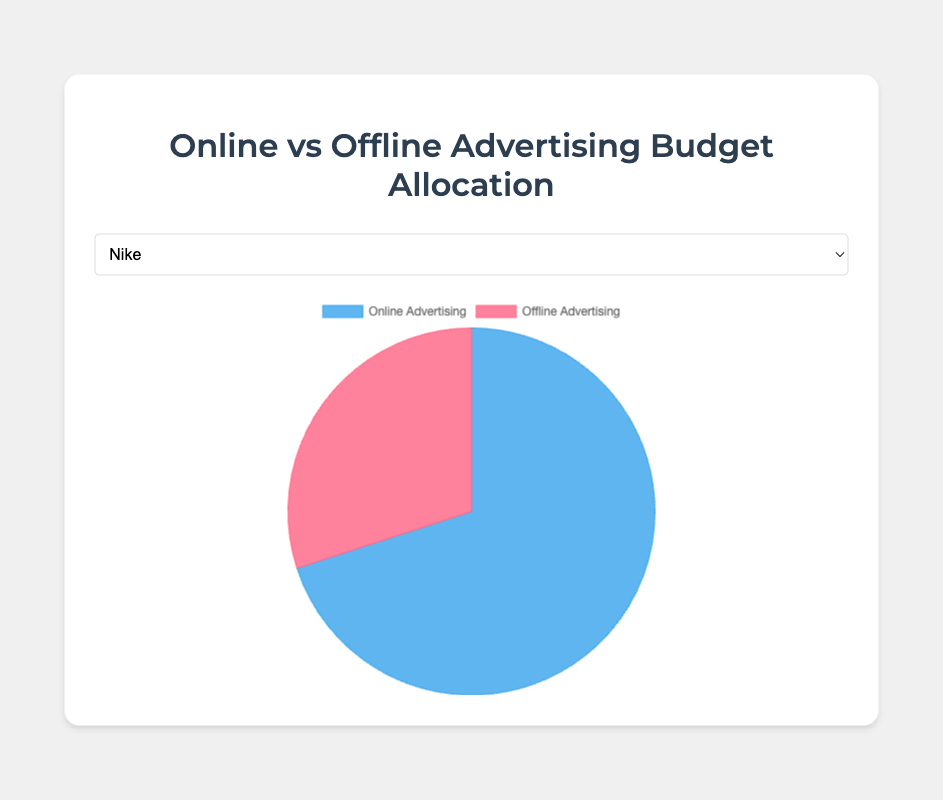Which company allocates the highest percentage to online advertising? By looking at the pie charts for each company, the segment representing online advertising is the largest for Nike at 70%.
Answer: Nike Which company has an equal distribution between online and offline advertising budgets? The pie chart for Pepsi shows that both segments are equal sized, each representing 50%.
Answer: Pepsi How much more does Samsung allocate to online advertising compared to offline advertising? Samsung's pie chart shows 65% for online and 35% for offline. The difference is 65% - 35% = 30%.
Answer: 30% Which company's offline advertising budget is 10% higher than its online advertising budget? By evaluating the pie charts, Apple's offline advertising budget is 40%, and its online is 60%, meaning offline is not 10% higher. No such company exists.
Answer: No such company What is the average online advertising budget percentage for Nike, Apple, and Coca-Cola combined? Nike: 70%, Apple: 60%, Coca-Cola: 55%. Average = (70 + 60 + 55) / 3 = 61.67%.
Answer: 61.67% If you combine the offline advertising budgets of Apple and Samsung, what percentage of the total combined budget for both companies does the offline advertising cover? Apple: 60+40 = 100%, Samsung: 65+35 = 100%. Offline combined: 40% (Apple) + 35% (Samsung) = 75%. Total combined budget is 100% + 100% = 200%. Therefore, the percentage is (75% / 200%) * 100 = 37.5%.
Answer: 37.5% How does the online advertising budget of Pepsi compare to the combined average online advertising budget of Coca-Cola and Samsung? Pepsi's online advertising budget is 50%. Coca-Cola is 55% and Samsung is 65%. Their average = (55% + 65%) / 2 = 60%. 50% (Pepsi) is 10% less than 60% (average of Coca-Cola and Samsung).
Answer: 50% is 10% less Which companies allocate more than 60% to online advertising? By observing the pie charts, Nike at 70% and Samsung at 65% allocate more than 60% to online advertising.
Answer: Nike, Samsung 